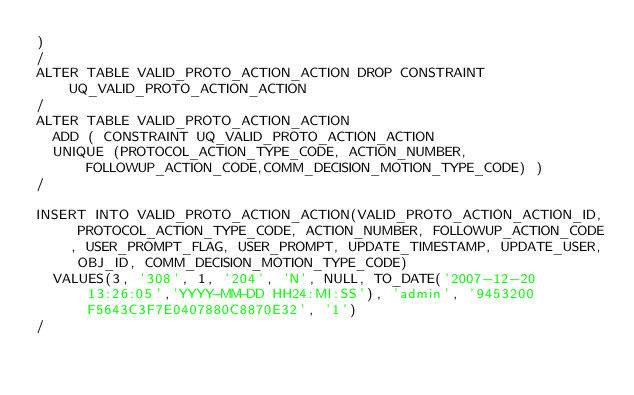<code> <loc_0><loc_0><loc_500><loc_500><_SQL_>)
/
ALTER TABLE VALID_PROTO_ACTION_ACTION DROP CONSTRAINT UQ_VALID_PROTO_ACTION_ACTION
/
ALTER TABLE VALID_PROTO_ACTION_ACTION
	ADD ( CONSTRAINT UQ_VALID_PROTO_ACTION_ACTION
	UNIQUE (PROTOCOL_ACTION_TYPE_CODE, ACTION_NUMBER, FOLLOWUP_ACTION_CODE,COMM_DECISION_MOTION_TYPE_CODE) )
/
   
INSERT INTO VALID_PROTO_ACTION_ACTION(VALID_PROTO_ACTION_ACTION_ID, PROTOCOL_ACTION_TYPE_CODE, ACTION_NUMBER, FOLLOWUP_ACTION_CODE, USER_PROMPT_FLAG, USER_PROMPT, UPDATE_TIMESTAMP, UPDATE_USER, OBJ_ID, COMM_DECISION_MOTION_TYPE_CODE)
  VALUES(3, '308', 1, '204', 'N', NULL, TO_DATE('2007-12-20 13:26:05','YYYY-MM-DD HH24:MI:SS'), 'admin', '9453200F5643C3F7E0407880C8870E32', '1')
/</code> 